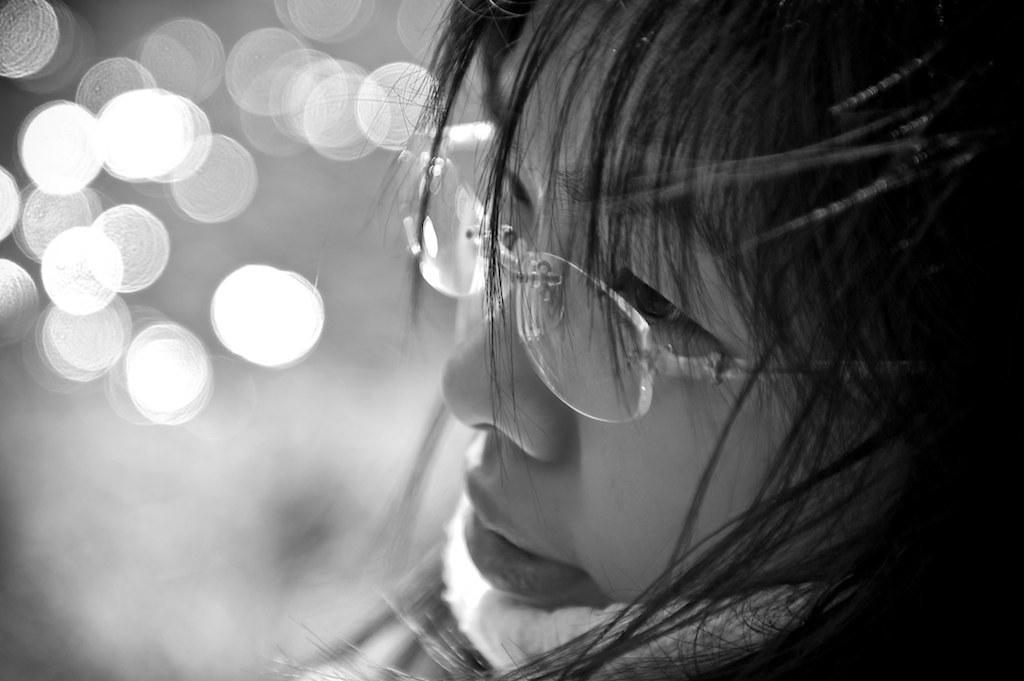What is the color scheme of the image? The image is black and white. Can you describe the woman's position? The woman is on the right side of the image and is facing forward. What is the woman wearing in the image? The woman is wearing spectacles in the image. What can be seen in the background of the image? There are blurred lights in the background of the image. What type of scarf is the woman wearing in the image? There is no scarf visible in the image; the woman is wearing spectacles. What effect does the woman have on the lift in the image? There is no lift present in the image, so it is not possible to determine any effect the woman might have on it. 